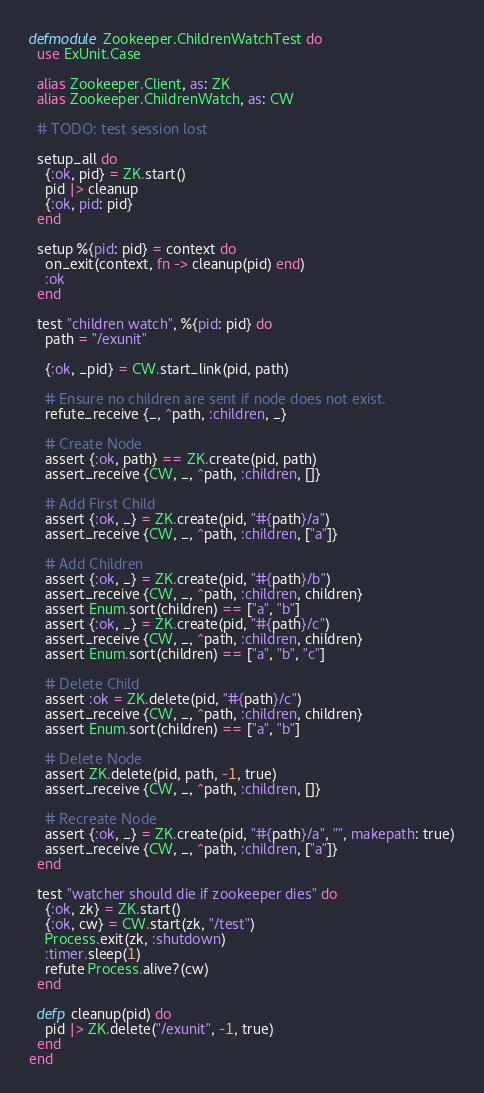<code> <loc_0><loc_0><loc_500><loc_500><_Elixir_>defmodule Zookeeper.ChildrenWatchTest do
  use ExUnit.Case

  alias Zookeeper.Client, as: ZK
  alias Zookeeper.ChildrenWatch, as: CW

  # TODO: test session lost

  setup_all do
    {:ok, pid} = ZK.start()
    pid |> cleanup
    {:ok, pid: pid}
  end

  setup %{pid: pid} = context do
    on_exit(context, fn -> cleanup(pid) end)
    :ok
  end

  test "children watch", %{pid: pid} do
    path = "/exunit"

    {:ok, _pid} = CW.start_link(pid, path)

    # Ensure no children are sent if node does not exist.
    refute_receive {_, ^path, :children, _}

    # Create Node
    assert {:ok, path} == ZK.create(pid, path)
    assert_receive {CW, _, ^path, :children, []}

    # Add First Child
    assert {:ok, _} = ZK.create(pid, "#{path}/a")
    assert_receive {CW, _, ^path, :children, ["a"]}

    # Add Children
    assert {:ok, _} = ZK.create(pid, "#{path}/b")
    assert_receive {CW, _, ^path, :children, children}
    assert Enum.sort(children) == ["a", "b"]
    assert {:ok, _} = ZK.create(pid, "#{path}/c")
    assert_receive {CW, _, ^path, :children, children}
    assert Enum.sort(children) == ["a", "b", "c"]

    # Delete Child
    assert :ok = ZK.delete(pid, "#{path}/c")
    assert_receive {CW, _, ^path, :children, children}
    assert Enum.sort(children) == ["a", "b"]

    # Delete Node
    assert ZK.delete(pid, path, -1, true)
    assert_receive {CW, _, ^path, :children, []}

    # Recreate Node
    assert {:ok, _} = ZK.create(pid, "#{path}/a", "", makepath: true)
    assert_receive {CW, _, ^path, :children, ["a"]}
  end

  test "watcher should die if zookeeper dies" do
    {:ok, zk} = ZK.start()
    {:ok, cw} = CW.start(zk, "/test")
    Process.exit(zk, :shutdown)
    :timer.sleep(1)
    refute Process.alive?(cw)
  end

  defp cleanup(pid) do
    pid |> ZK.delete("/exunit", -1, true)
  end
end
</code> 